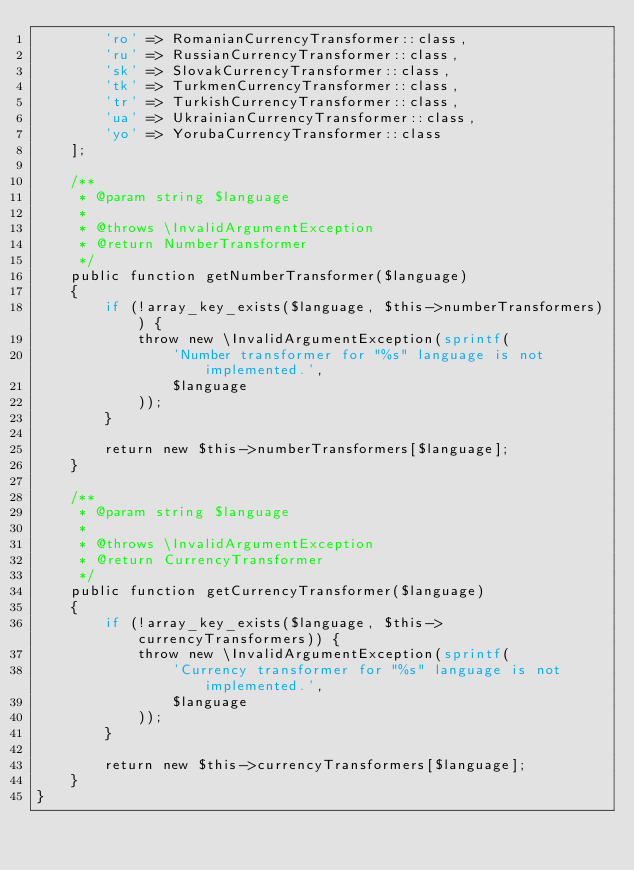<code> <loc_0><loc_0><loc_500><loc_500><_PHP_>        'ro' => RomanianCurrencyTransformer::class,
        'ru' => RussianCurrencyTransformer::class,
        'sk' => SlovakCurrencyTransformer::class,
        'tk' => TurkmenCurrencyTransformer::class,
        'tr' => TurkishCurrencyTransformer::class,
        'ua' => UkrainianCurrencyTransformer::class,
        'yo' => YorubaCurrencyTransformer::class
    ];

    /**
     * @param string $language
     *
     * @throws \InvalidArgumentException
     * @return NumberTransformer
     */
    public function getNumberTransformer($language)
    {
        if (!array_key_exists($language, $this->numberTransformers)) {
            throw new \InvalidArgumentException(sprintf(
                'Number transformer for "%s" language is not implemented.',
                $language
            ));
        }

        return new $this->numberTransformers[$language];
    }

    /**
     * @param string $language
     *
     * @throws \InvalidArgumentException
     * @return CurrencyTransformer
     */
    public function getCurrencyTransformer($language)
    {
        if (!array_key_exists($language, $this->currencyTransformers)) {
            throw new \InvalidArgumentException(sprintf(
                'Currency transformer for "%s" language is not implemented.',
                $language
            ));
        }

        return new $this->currencyTransformers[$language];
    }
}
</code> 